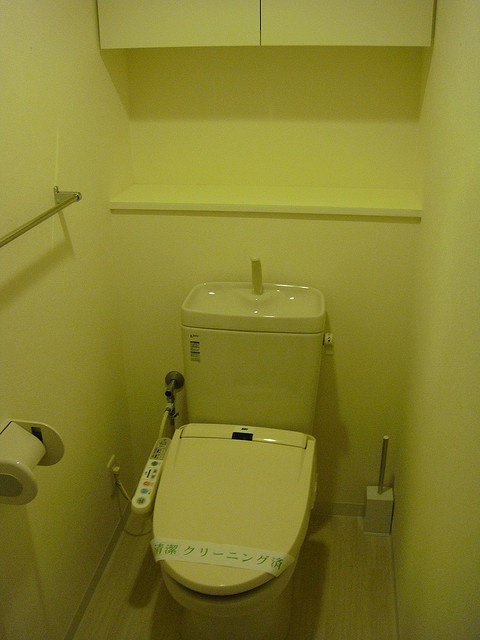Describe the objects in this image and their specific colors. I can see a toilet in tan, olive, and darkgreen tones in this image. 